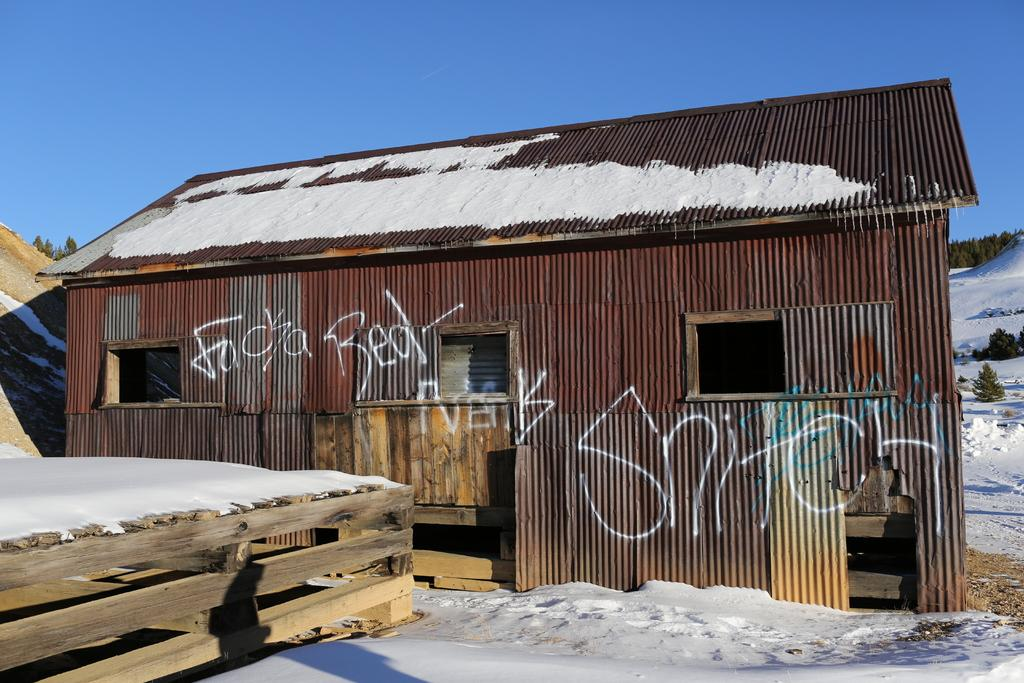What type of structure is present in the image? There is a shed with windows in the image. Are there any words or text on the shed? Yes, there are words on the shed. What is the condition of the ground in the image? There is snow on the ground in the image. What type of fencing is visible in the image? There is a wooden fencing in the image. What can be seen in the background of the image? Trees and the sky are visible in the background of the image. What type of education is being offered at the station in the image? There is no station present in the image, and therefore no education is being offered. What level of experience is required for the beginner in the image? There is no activity or skill being demonstrated in the image that would require a beginner level of experience. 